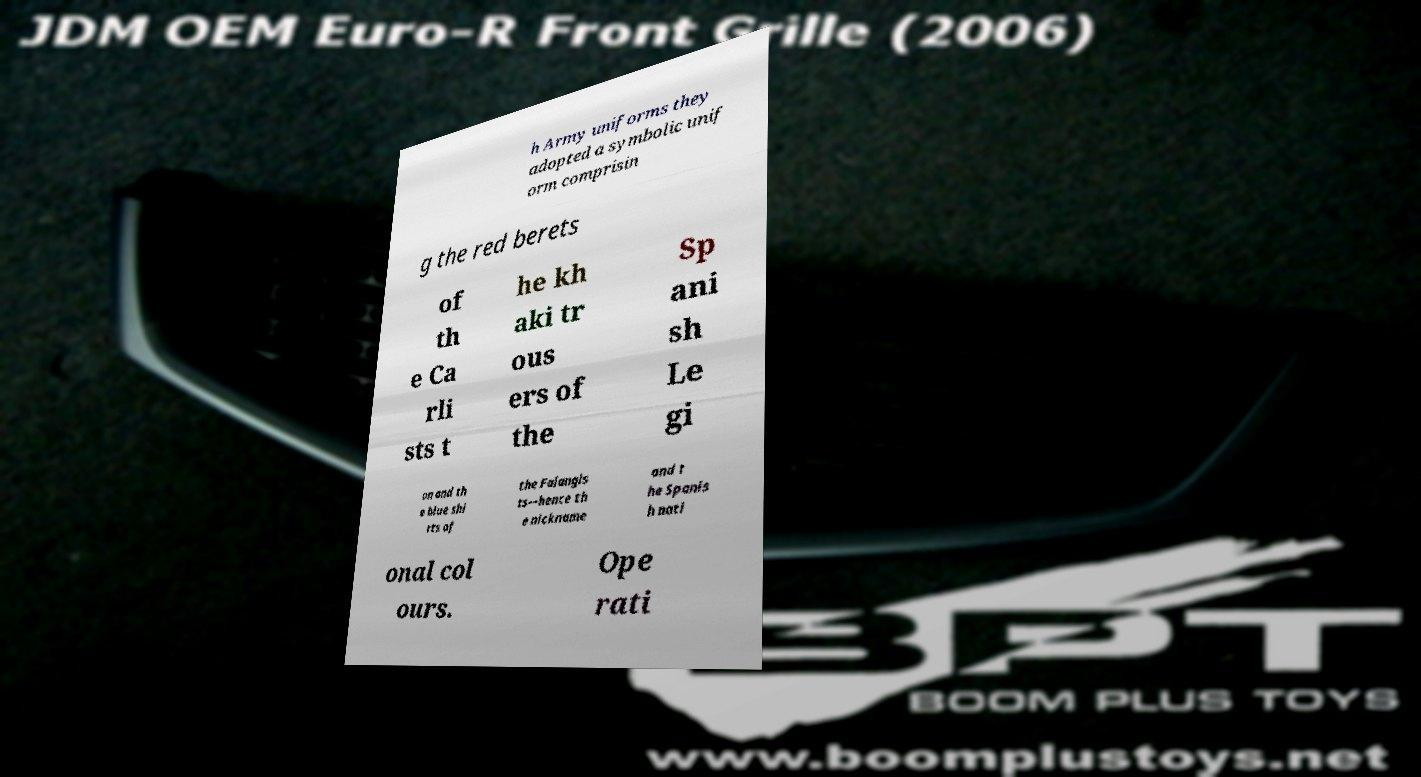Please identify and transcribe the text found in this image. h Army uniforms they adopted a symbolic unif orm comprisin g the red berets of th e Ca rli sts t he kh aki tr ous ers of the Sp ani sh Le gi on and th e blue shi rts of the Falangis ts—hence th e nickname and t he Spanis h nati onal col ours. Ope rati 